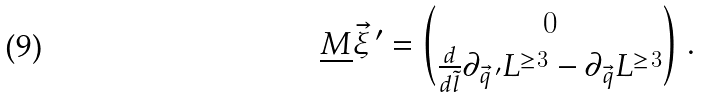Convert formula to latex. <formula><loc_0><loc_0><loc_500><loc_500>\underline { M } { \vec { \xi } } ^ { \, \prime } = { 0 \choose \frac { d } { d \tilde { l } } \partial _ { { \vec { q } } ^ { \, \prime } } L ^ { \geq 3 } - \partial _ { \vec { q } } L ^ { \geq 3 } } \ .</formula> 